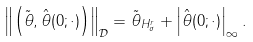<formula> <loc_0><loc_0><loc_500><loc_500>\left \| \left ( { \tilde { \theta } } , { \hat { \theta } } ( 0 ; \cdot ) \right ) \right \| _ { \mathcal { D } } = \| { \tilde { \theta } } \| _ { H ^ { r } _ { \sigma } } + \left | { \hat { \theta } } ( 0 ; \cdot ) \right | _ { \infty } .</formula> 